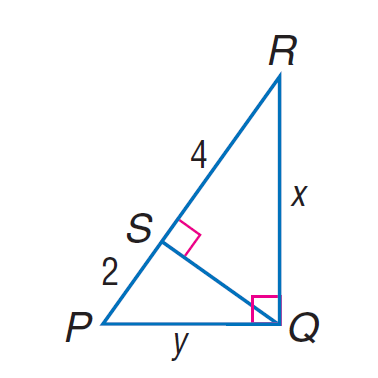Answer the mathemtical geometry problem and directly provide the correct option letter.
Question: Find x in \triangle P Q R.
Choices: A: 2 \sqrt { 3 } B: 2 \sqrt { 6 } C: 4 \sqrt { 3 } D: 4 \sqrt { 6 } B 